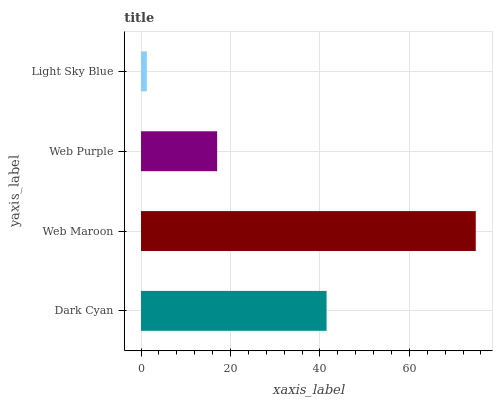Is Light Sky Blue the minimum?
Answer yes or no. Yes. Is Web Maroon the maximum?
Answer yes or no. Yes. Is Web Purple the minimum?
Answer yes or no. No. Is Web Purple the maximum?
Answer yes or no. No. Is Web Maroon greater than Web Purple?
Answer yes or no. Yes. Is Web Purple less than Web Maroon?
Answer yes or no. Yes. Is Web Purple greater than Web Maroon?
Answer yes or no. No. Is Web Maroon less than Web Purple?
Answer yes or no. No. Is Dark Cyan the high median?
Answer yes or no. Yes. Is Web Purple the low median?
Answer yes or no. Yes. Is Web Maroon the high median?
Answer yes or no. No. Is Light Sky Blue the low median?
Answer yes or no. No. 